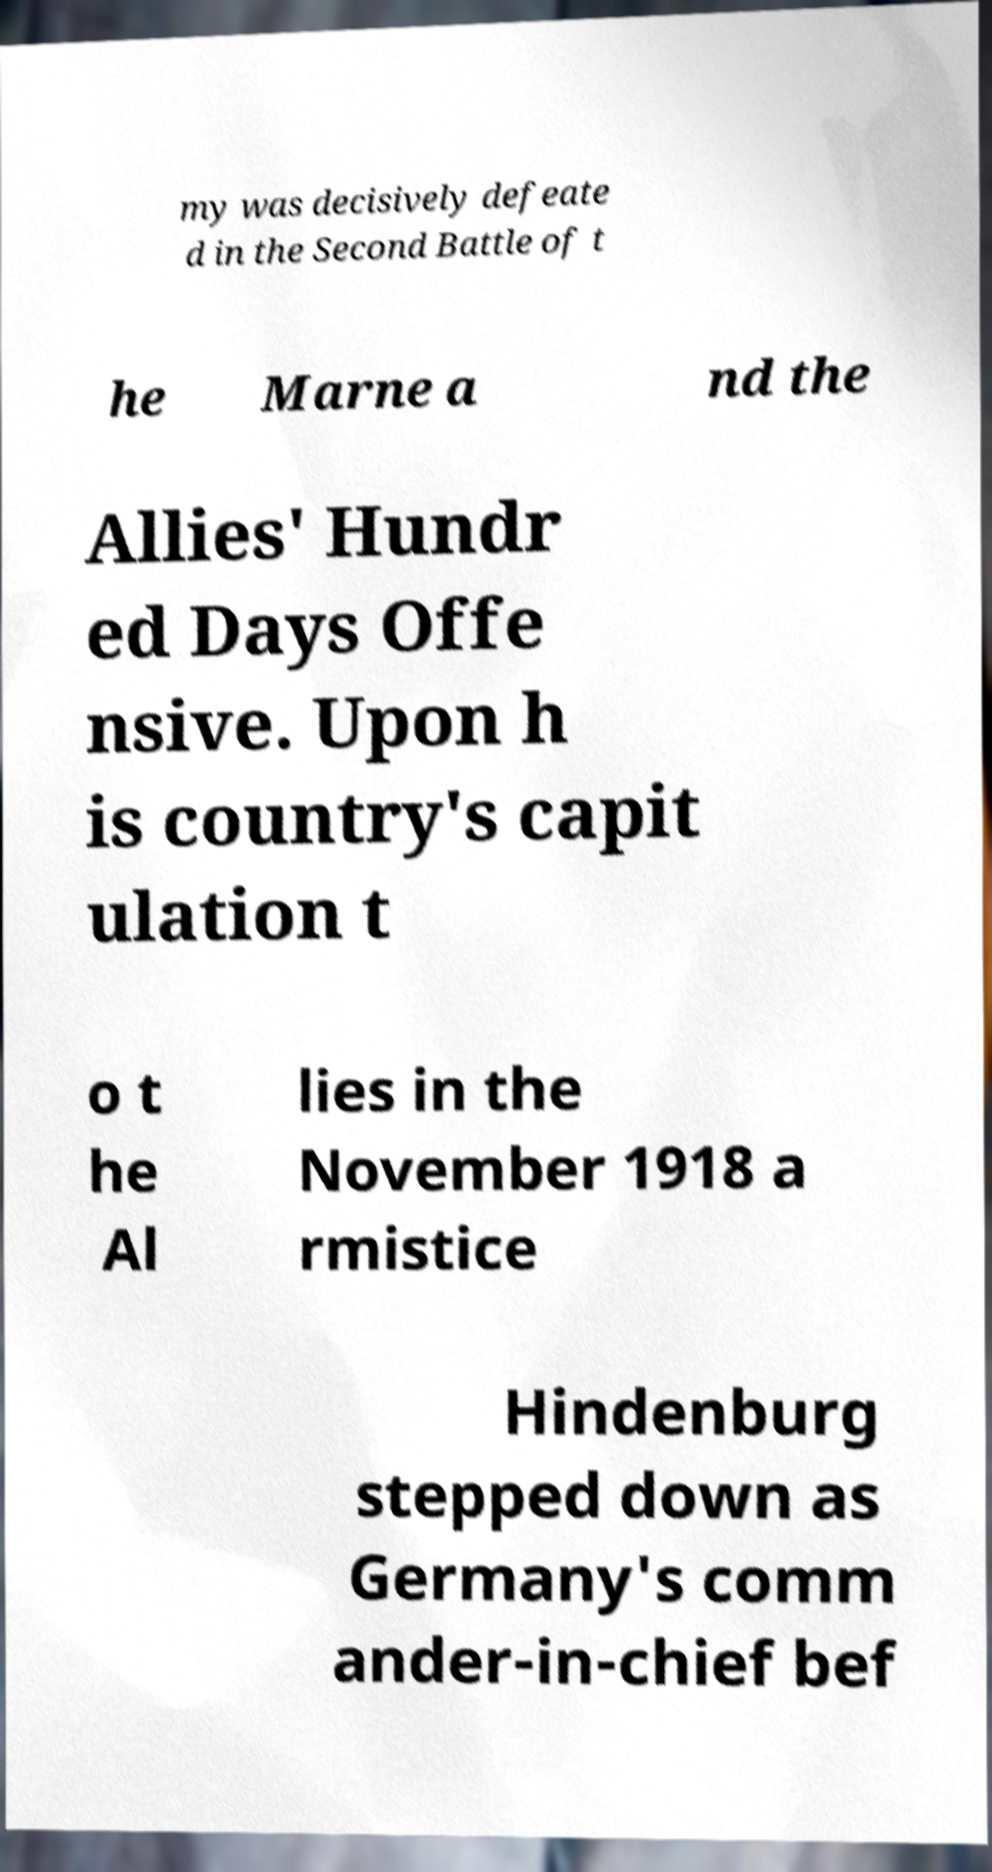For documentation purposes, I need the text within this image transcribed. Could you provide that? my was decisively defeate d in the Second Battle of t he Marne a nd the Allies' Hundr ed Days Offe nsive. Upon h is country's capit ulation t o t he Al lies in the November 1918 a rmistice Hindenburg stepped down as Germany's comm ander-in-chief bef 